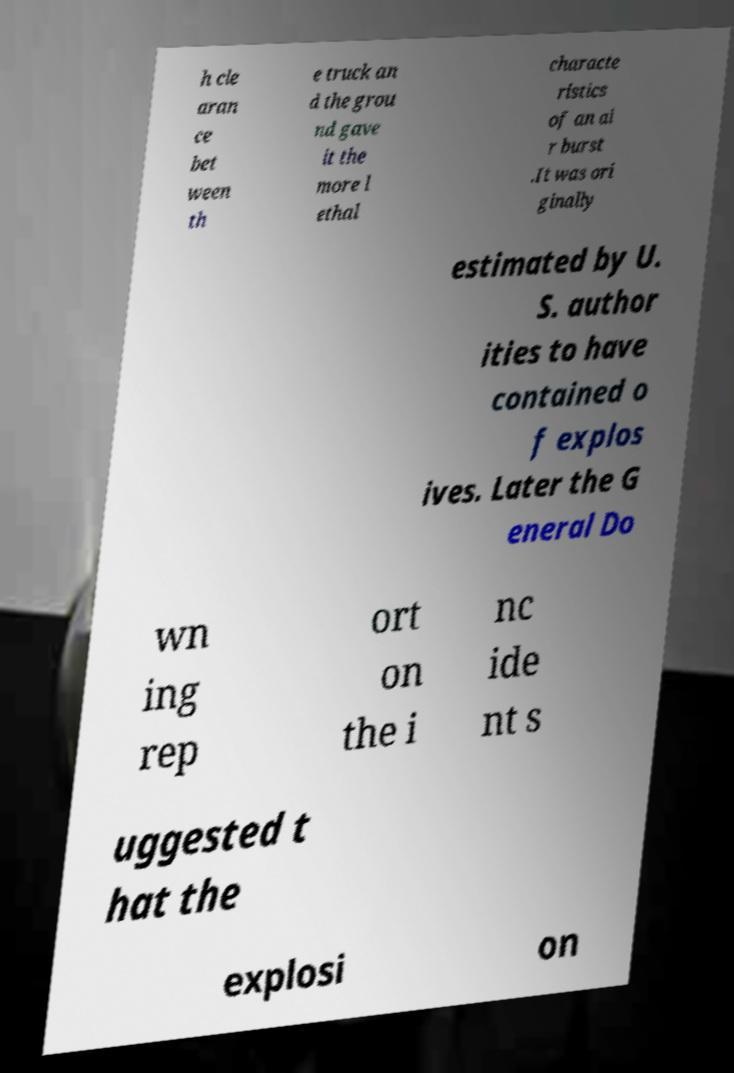Could you assist in decoding the text presented in this image and type it out clearly? h cle aran ce bet ween th e truck an d the grou nd gave it the more l ethal characte ristics of an ai r burst .It was ori ginally estimated by U. S. author ities to have contained o f explos ives. Later the G eneral Do wn ing rep ort on the i nc ide nt s uggested t hat the explosi on 